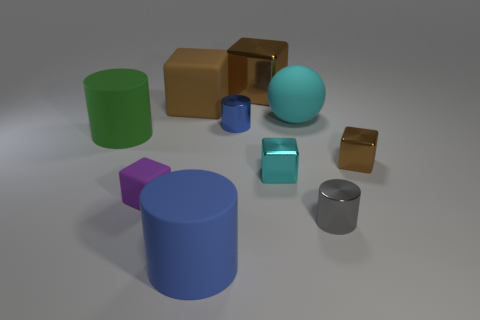Subtract all brown cylinders. How many brown blocks are left? 3 Subtract all big matte cubes. How many cubes are left? 4 Subtract all cyan cubes. How many cubes are left? 4 Subtract all cyan cubes. Subtract all gray balls. How many cubes are left? 4 Subtract all balls. How many objects are left? 9 Subtract 0 yellow cylinders. How many objects are left? 10 Subtract all small red matte balls. Subtract all large green matte cylinders. How many objects are left? 9 Add 7 large cubes. How many large cubes are left? 9 Add 4 big yellow balls. How many big yellow balls exist? 4 